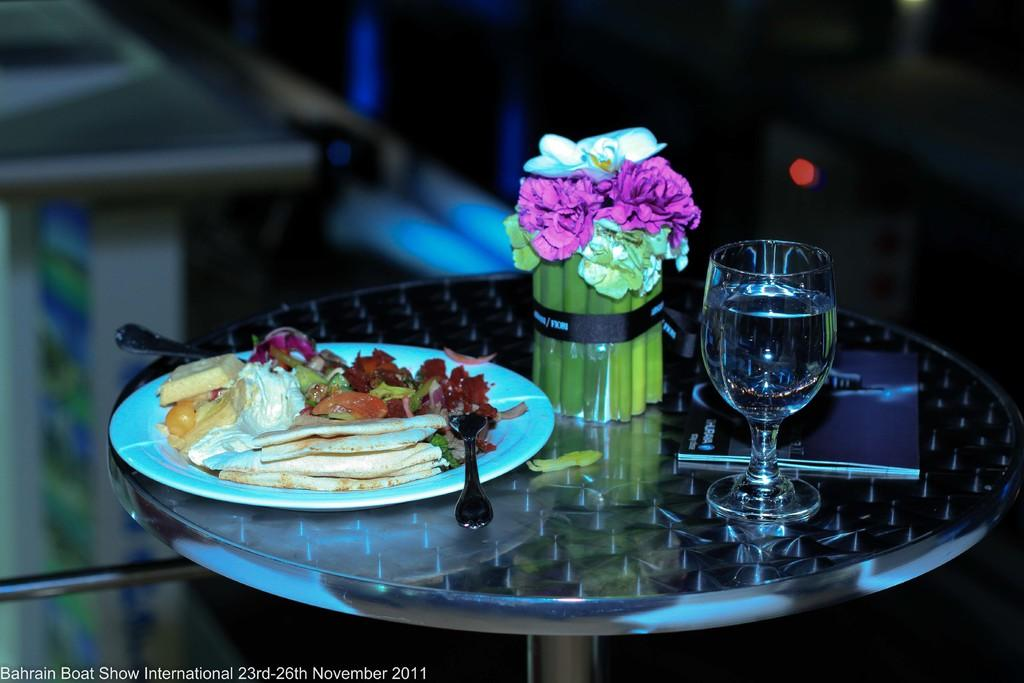What is on the table in the image? There is a glass, a book, a plate, a spoon, and flowers on the table. What else can be seen on the table? There is food on the table. What might be used for eating or drinking in the image? The glass and spoon on the table can be used for drinking and eating, respectively. What type of decoration is present on the table? Flowers are present on the table as a decoration. What is the reason for the sleet in the image? There is no sleet present in the image; the background is blurred, but it does not indicate any weather conditions. How does the death of the flowers affect the image? There is no indication of any flowers dying in the image; the flowers are present as a decoration on the table. 